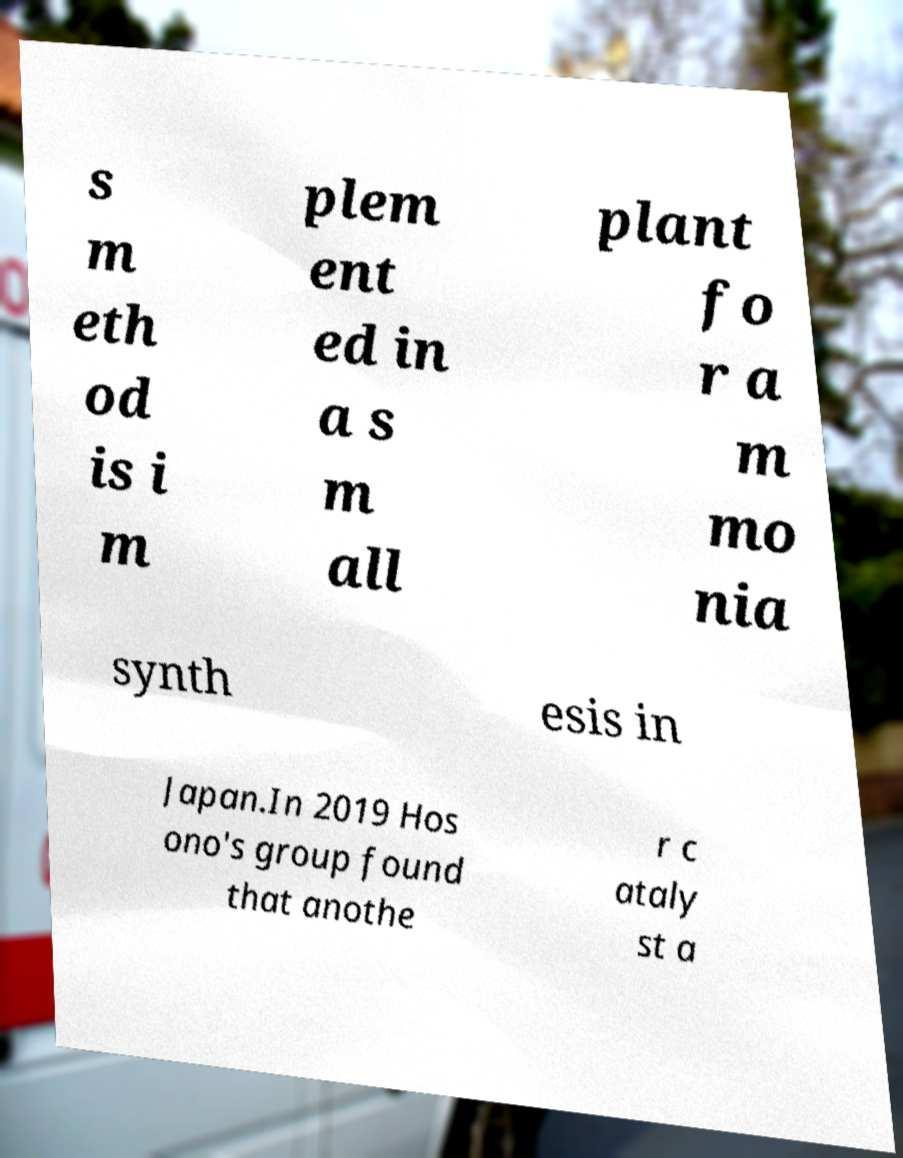Can you read and provide the text displayed in the image?This photo seems to have some interesting text. Can you extract and type it out for me? s m eth od is i m plem ent ed in a s m all plant fo r a m mo nia synth esis in Japan.In 2019 Hos ono's group found that anothe r c ataly st a 